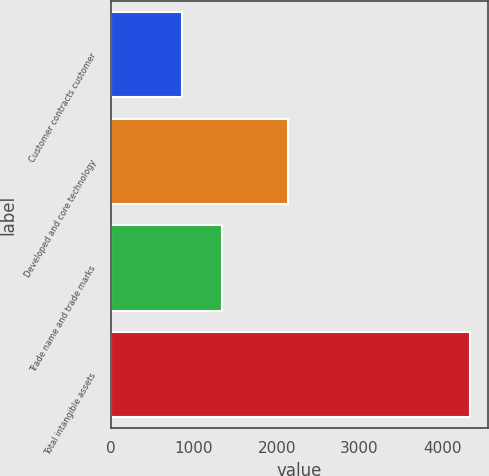<chart> <loc_0><loc_0><loc_500><loc_500><bar_chart><fcel>Customer contracts customer<fcel>Developed and core technology<fcel>Trade name and trade marks<fcel>Total intangible assets<nl><fcel>856<fcel>2138<fcel>1336<fcel>4330<nl></chart> 